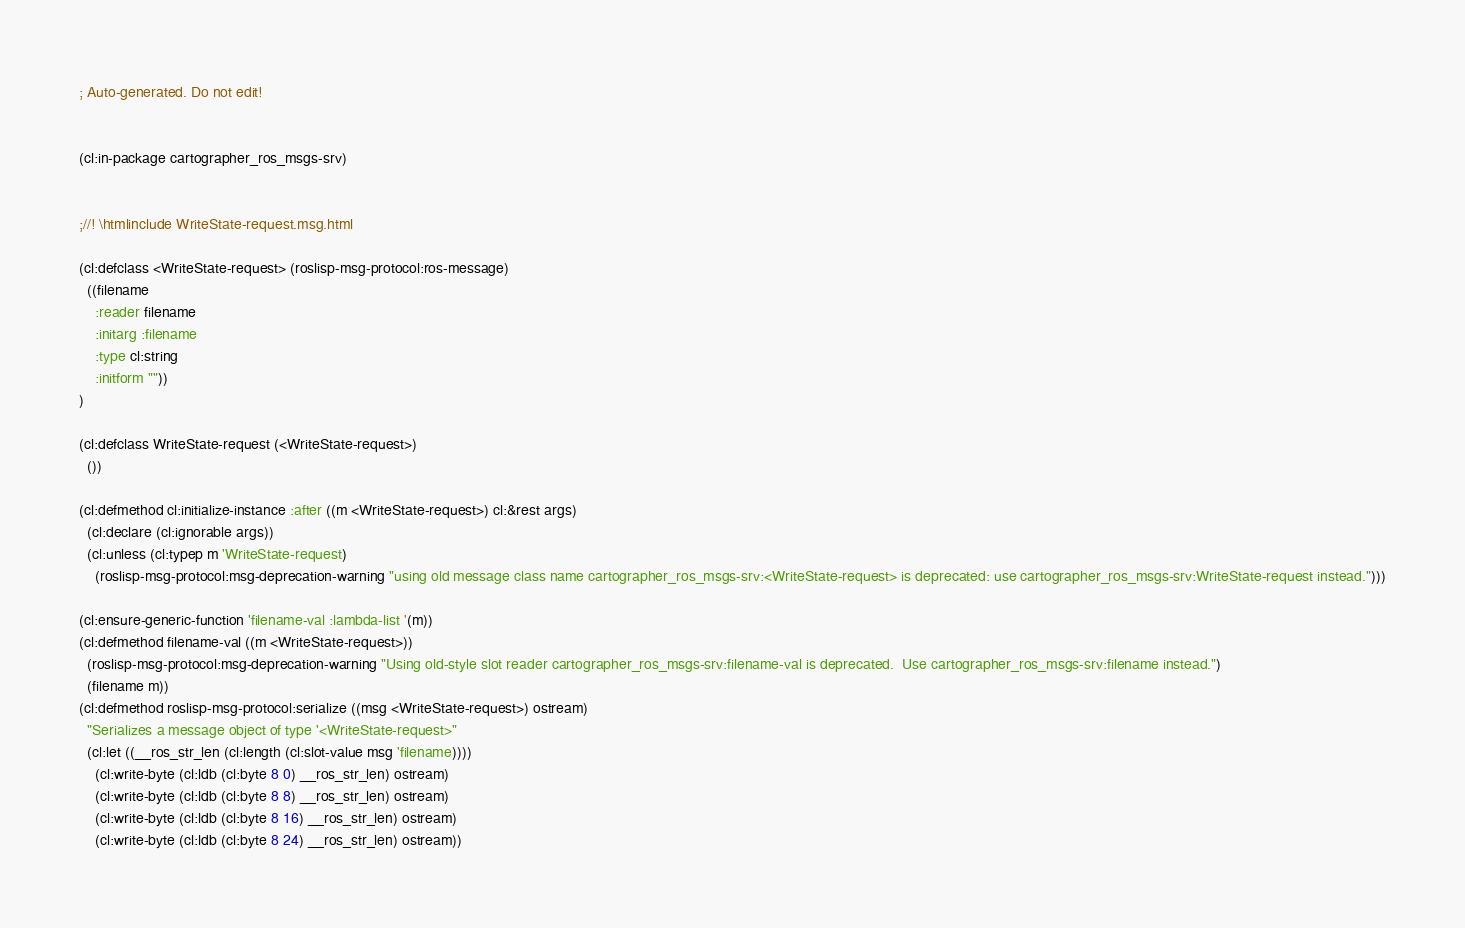Convert code to text. <code><loc_0><loc_0><loc_500><loc_500><_Lisp_>; Auto-generated. Do not edit!


(cl:in-package cartographer_ros_msgs-srv)


;//! \htmlinclude WriteState-request.msg.html

(cl:defclass <WriteState-request> (roslisp-msg-protocol:ros-message)
  ((filename
    :reader filename
    :initarg :filename
    :type cl:string
    :initform ""))
)

(cl:defclass WriteState-request (<WriteState-request>)
  ())

(cl:defmethod cl:initialize-instance :after ((m <WriteState-request>) cl:&rest args)
  (cl:declare (cl:ignorable args))
  (cl:unless (cl:typep m 'WriteState-request)
    (roslisp-msg-protocol:msg-deprecation-warning "using old message class name cartographer_ros_msgs-srv:<WriteState-request> is deprecated: use cartographer_ros_msgs-srv:WriteState-request instead.")))

(cl:ensure-generic-function 'filename-val :lambda-list '(m))
(cl:defmethod filename-val ((m <WriteState-request>))
  (roslisp-msg-protocol:msg-deprecation-warning "Using old-style slot reader cartographer_ros_msgs-srv:filename-val is deprecated.  Use cartographer_ros_msgs-srv:filename instead.")
  (filename m))
(cl:defmethod roslisp-msg-protocol:serialize ((msg <WriteState-request>) ostream)
  "Serializes a message object of type '<WriteState-request>"
  (cl:let ((__ros_str_len (cl:length (cl:slot-value msg 'filename))))
    (cl:write-byte (cl:ldb (cl:byte 8 0) __ros_str_len) ostream)
    (cl:write-byte (cl:ldb (cl:byte 8 8) __ros_str_len) ostream)
    (cl:write-byte (cl:ldb (cl:byte 8 16) __ros_str_len) ostream)
    (cl:write-byte (cl:ldb (cl:byte 8 24) __ros_str_len) ostream))</code> 